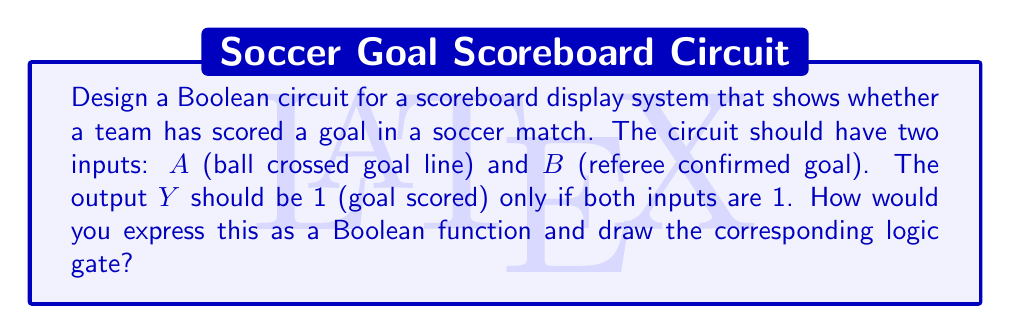Teach me how to tackle this problem. To design this Boolean circuit, we'll follow these steps:

1. Identify the inputs and output:
   - Input $A$: Ball crossed goal line (1 if true, 0 if false)
   - Input $B$: Referee confirmed goal (1 if true, 0 if false)
   - Output $Y$: Goal scored (1 if true, 0 if false)

2. Determine the Boolean function:
   We want $Y$ to be 1 only when both $A$ and $B$ are 1. This is the definition of the AND operation in Boolean algebra.

3. Express the Boolean function:
   $Y = A \cdot B$ (where $\cdot$ represents the AND operation)

4. Draw the logic gate:
   The AND gate is used to implement this function.

[asy]
import geometry;

pair A = (0,20);
pair B = (0,0);
pair C = (40,10);

draw(A--(-10,20));
draw(B--(-10,0));
draw(C--(50,10));

path p = (10,0)..(20,0)..(30,20)..(10,20)--cycle;
fill(p,gray(0.9));
draw(p);

label("A", (-12,20), W);
label("B", (-12,0), W);
label("Y", (52,10), E);

label("AND", (20,10));
[/asy]

5. Truth table for verification:

   | $A$ | $B$ | $Y$ |
   |-----|-----|-----|
   |  0  |  0  |  0  |
   |  0  |  1  |  0  |
   |  1  |  0  |  0  |
   |  1  |  1  |  1  |

This circuit ensures that a goal is only displayed on the scoreboard when both conditions (ball crossed goal line and referee confirmation) are met, which is crucial for accurate scoring in international soccer competitions.
Answer: $Y = A \cdot B$, AND gate 